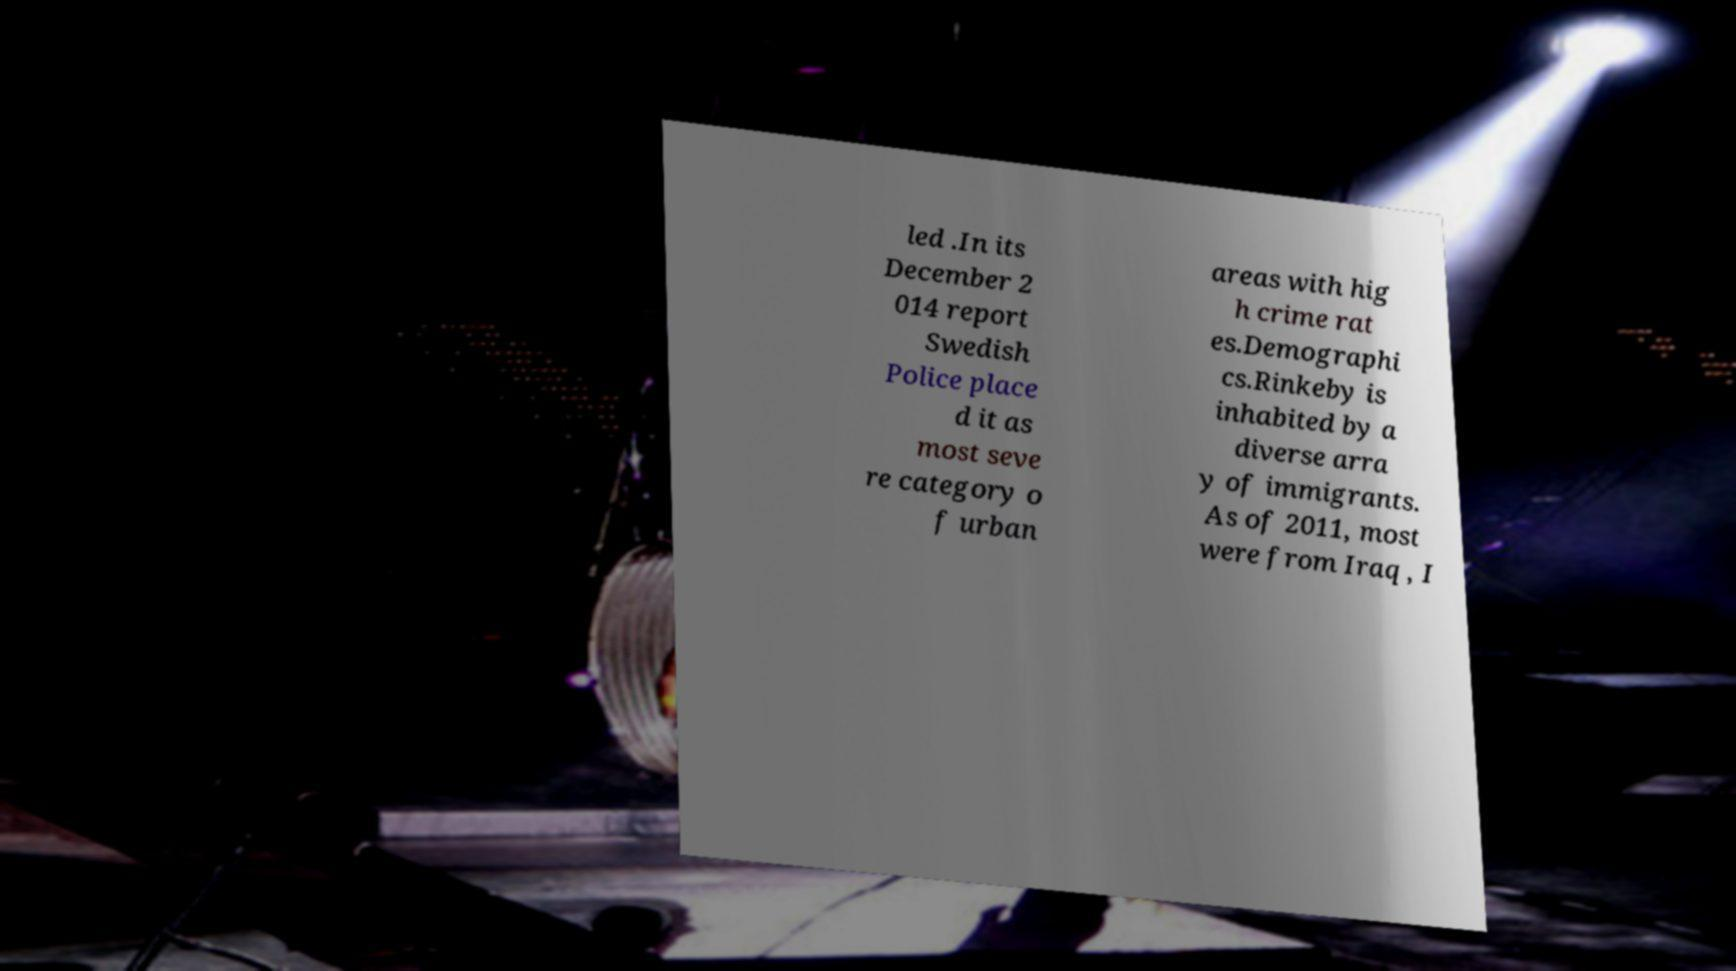Could you extract and type out the text from this image? led .In its December 2 014 report Swedish Police place d it as most seve re category o f urban areas with hig h crime rat es.Demographi cs.Rinkeby is inhabited by a diverse arra y of immigrants. As of 2011, most were from Iraq , I 